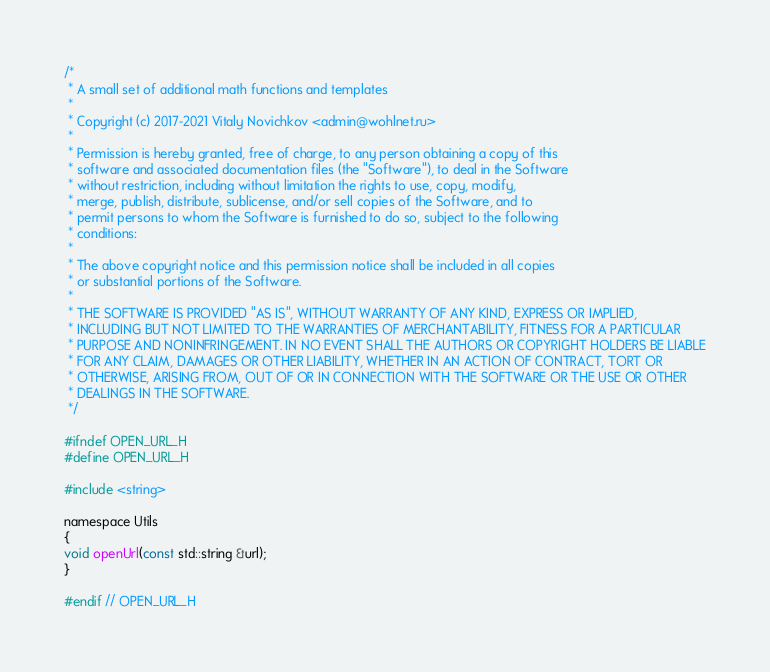Convert code to text. <code><loc_0><loc_0><loc_500><loc_500><_C_>/*
 * A small set of additional math functions and templates
 *
 * Copyright (c) 2017-2021 Vitaly Novichkov <admin@wohlnet.ru>
 *
 * Permission is hereby granted, free of charge, to any person obtaining a copy of this
 * software and associated documentation files (the "Software"), to deal in the Software
 * without restriction, including without limitation the rights to use, copy, modify,
 * merge, publish, distribute, sublicense, and/or sell copies of the Software, and to
 * permit persons to whom the Software is furnished to do so, subject to the following
 * conditions:
 *
 * The above copyright notice and this permission notice shall be included in all copies
 * or substantial portions of the Software.
 *
 * THE SOFTWARE IS PROVIDED "AS IS", WITHOUT WARRANTY OF ANY KIND, EXPRESS OR IMPLIED,
 * INCLUDING BUT NOT LIMITED TO THE WARRANTIES OF MERCHANTABILITY, FITNESS FOR A PARTICULAR
 * PURPOSE AND NONINFRINGEMENT. IN NO EVENT SHALL THE AUTHORS OR COPYRIGHT HOLDERS BE LIABLE
 * FOR ANY CLAIM, DAMAGES OR OTHER LIABILITY, WHETHER IN AN ACTION OF CONTRACT, TORT OR
 * OTHERWISE, ARISING FROM, OUT OF OR IN CONNECTION WITH THE SOFTWARE OR THE USE OR OTHER
 * DEALINGS IN THE SOFTWARE.
 */

#ifndef OPEN_URL_H
#define OPEN_URL_H

#include <string>

namespace Utils
{
void openUrl(const std::string &url);
}

#endif // OPEN_URL_H
</code> 